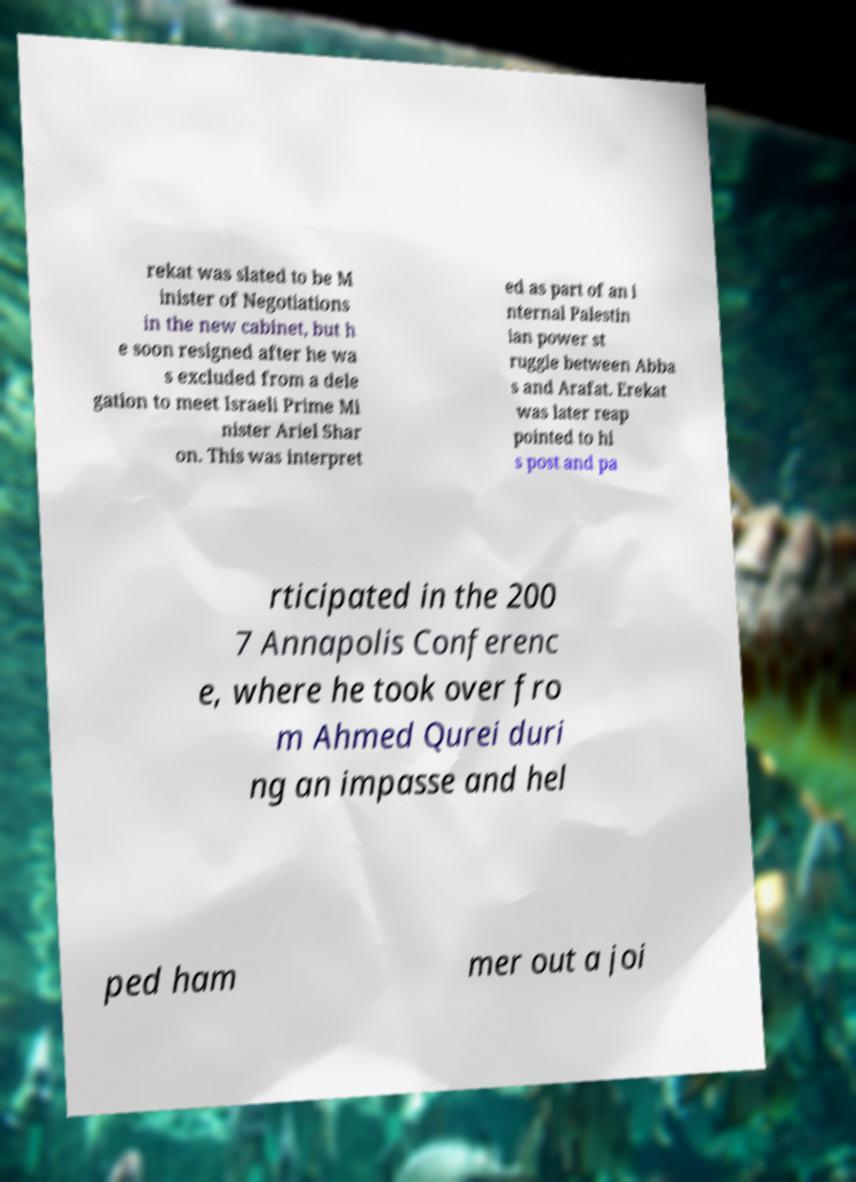What messages or text are displayed in this image? I need them in a readable, typed format. rekat was slated to be M inister of Negotiations in the new cabinet, but h e soon resigned after he wa s excluded from a dele gation to meet Israeli Prime Mi nister Ariel Shar on. This was interpret ed as part of an i nternal Palestin ian power st ruggle between Abba s and Arafat. Erekat was later reap pointed to hi s post and pa rticipated in the 200 7 Annapolis Conferenc e, where he took over fro m Ahmed Qurei duri ng an impasse and hel ped ham mer out a joi 